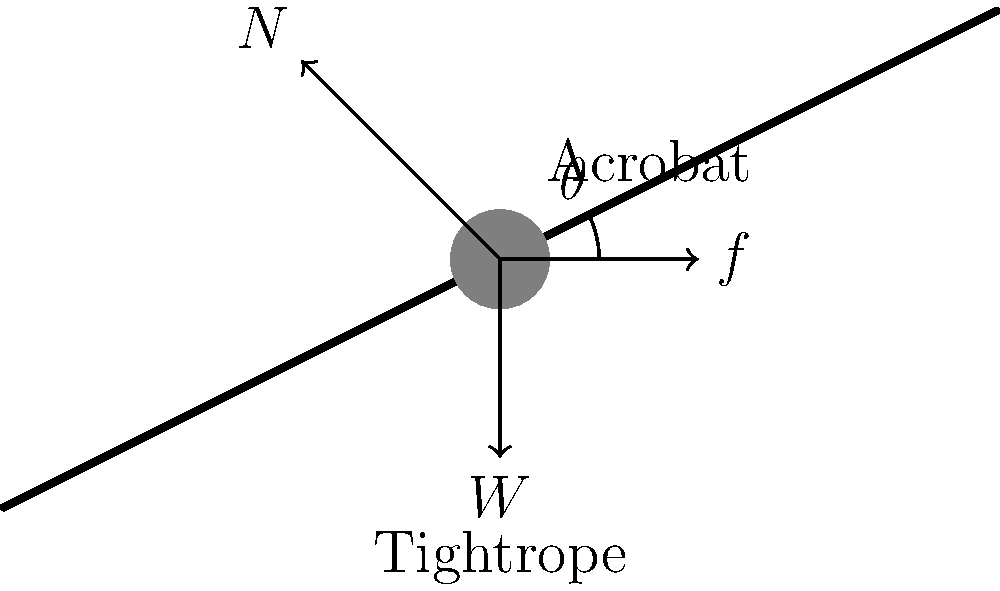An acrobat is balancing on a slanted tightrope that makes an angle of $26.57°$ with the horizontal. The acrobat's mass is 65 kg. If the acrobat is at rest, what is the coefficient of static friction $\mu_s$ between the acrobat's shoes and the tightrope? To solve this problem, we'll follow these steps:

1) First, let's identify the forces acting on the acrobat:
   - Weight (W): acts downward
   - Normal force (N): perpendicular to the tightrope
   - Friction force (f): parallel to the tightrope, opposing sliding

2) Since the acrobat is at rest, the sum of forces must be zero in both x and y directions.

3) Let's resolve the forces along and perpendicular to the tightrope:
   - Along the tightrope: $f - W \sin\theta = 0$
   - Perpendicular to the tightrope: $N - W \cos\theta = 0$

4) From the second equation:
   $N = W \cos\theta$

5) We know that $f = \mu_s N$ (definition of static friction)

6) Substituting this into the first equation:
   $\mu_s N - W \sin\theta = 0$

7) Substituting $N$ from step 4:
   $\mu_s (W \cos\theta) - W \sin\theta = 0$

8) Simplify:
   $\mu_s \cos\theta = \sin\theta$

9) Solve for $\mu_s$:
   $\mu_s = \frac{\sin\theta}{\cos\theta} = \tan\theta$

10) Calculate:
    $\mu_s = \tan(26.57°) = 0.5$

Therefore, the coefficient of static friction is 0.5.
Answer: 0.5 